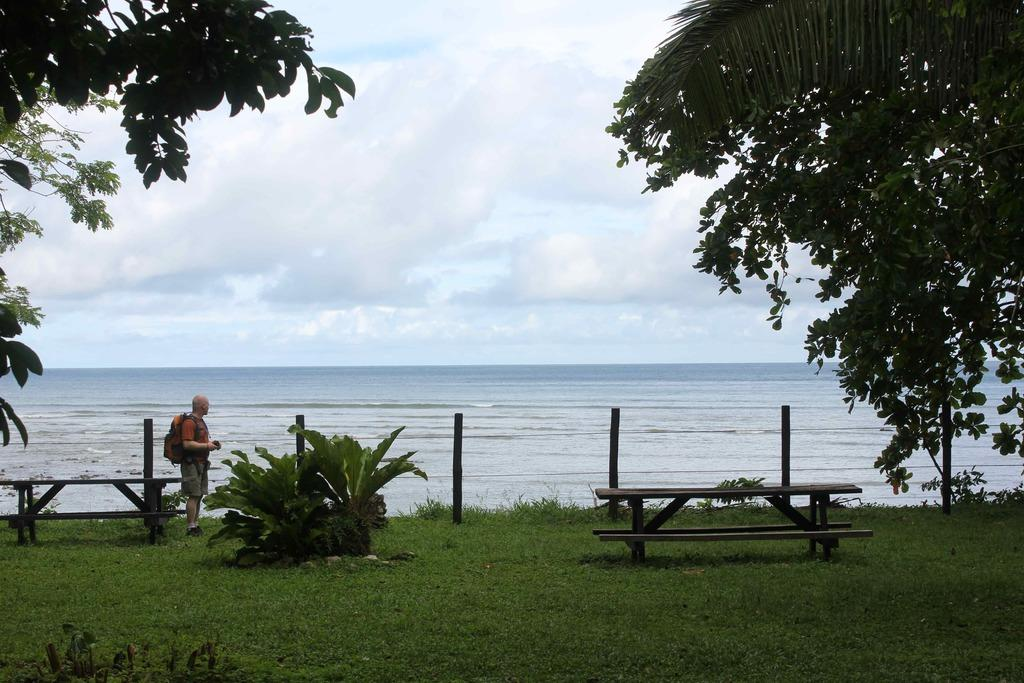Where is the setting of the image? The image is set outside near the sea. Can you describe the person in the image? There is a man standing in the image. What type of seating is available in the image? There are benches in the image. What can be seen in the background of the image? There are trees in the image. How would you describe the weather in the image? The sky is cloudy in the image. What is the man carrying in the image? The man is carrying a bag. Can you tell me how many yaks are visible in the image? There are no yaks present in the image. What type of thrill can be experienced by the man in the image? The image does not provide any information about the man's emotions or experiences, so it is impossible to determine if he is experiencing any thrill. 